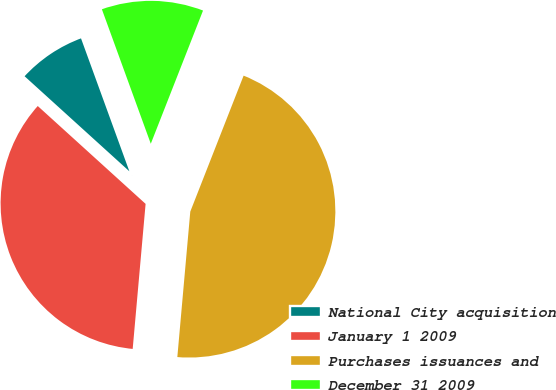Convert chart to OTSL. <chart><loc_0><loc_0><loc_500><loc_500><pie_chart><fcel>National City acquisition<fcel>January 1 2009<fcel>Purchases issuances and<fcel>December 31 2009<nl><fcel>7.72%<fcel>35.31%<fcel>45.46%<fcel>11.5%<nl></chart> 